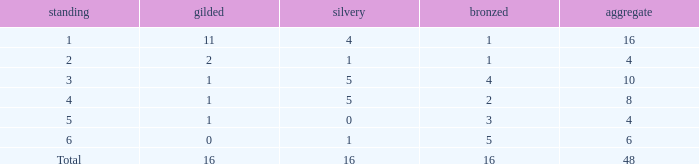How many gold are a rank 1 and larger than 16? 0.0. 